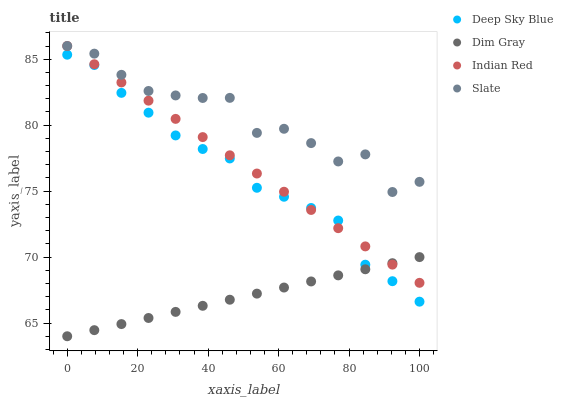Does Dim Gray have the minimum area under the curve?
Answer yes or no. Yes. Does Slate have the maximum area under the curve?
Answer yes or no. Yes. Does Indian Red have the minimum area under the curve?
Answer yes or no. No. Does Indian Red have the maximum area under the curve?
Answer yes or no. No. Is Indian Red the smoothest?
Answer yes or no. Yes. Is Slate the roughest?
Answer yes or no. Yes. Is Dim Gray the smoothest?
Answer yes or no. No. Is Dim Gray the roughest?
Answer yes or no. No. Does Dim Gray have the lowest value?
Answer yes or no. Yes. Does Indian Red have the lowest value?
Answer yes or no. No. Does Indian Red have the highest value?
Answer yes or no. Yes. Does Dim Gray have the highest value?
Answer yes or no. No. Is Deep Sky Blue less than Slate?
Answer yes or no. Yes. Is Slate greater than Deep Sky Blue?
Answer yes or no. Yes. Does Dim Gray intersect Deep Sky Blue?
Answer yes or no. Yes. Is Dim Gray less than Deep Sky Blue?
Answer yes or no. No. Is Dim Gray greater than Deep Sky Blue?
Answer yes or no. No. Does Deep Sky Blue intersect Slate?
Answer yes or no. No. 